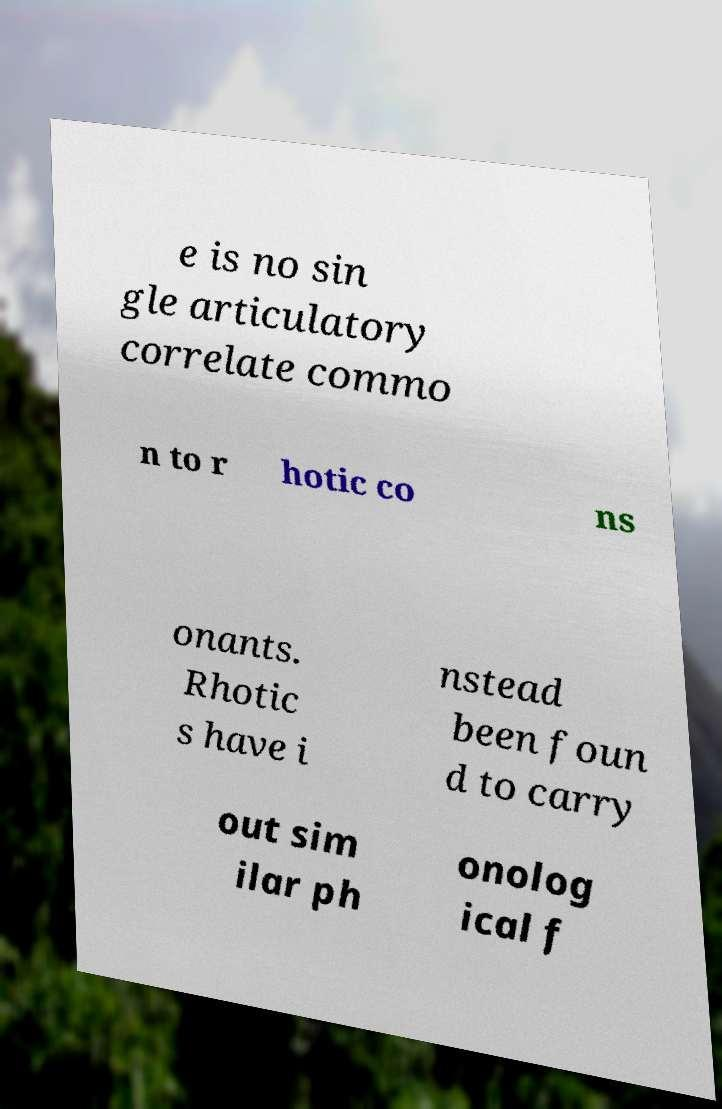Could you extract and type out the text from this image? e is no sin gle articulatory correlate commo n to r hotic co ns onants. Rhotic s have i nstead been foun d to carry out sim ilar ph onolog ical f 